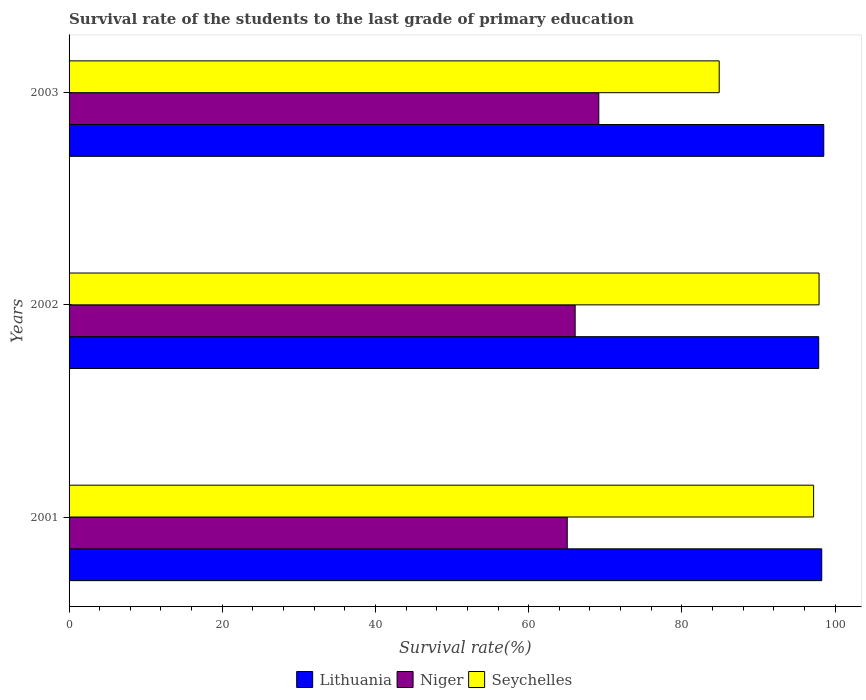How many different coloured bars are there?
Give a very brief answer. 3. Are the number of bars per tick equal to the number of legend labels?
Provide a succinct answer. Yes. Are the number of bars on each tick of the Y-axis equal?
Make the answer very short. Yes. How many bars are there on the 2nd tick from the top?
Make the answer very short. 3. How many bars are there on the 2nd tick from the bottom?
Provide a succinct answer. 3. What is the label of the 2nd group of bars from the top?
Provide a short and direct response. 2002. In how many cases, is the number of bars for a given year not equal to the number of legend labels?
Your answer should be very brief. 0. What is the survival rate of the students in Niger in 2002?
Your answer should be very brief. 66.07. Across all years, what is the maximum survival rate of the students in Niger?
Your answer should be compact. 69.16. Across all years, what is the minimum survival rate of the students in Seychelles?
Your answer should be very brief. 84.88. In which year was the survival rate of the students in Niger maximum?
Your answer should be compact. 2003. In which year was the survival rate of the students in Seychelles minimum?
Your answer should be very brief. 2003. What is the total survival rate of the students in Lithuania in the graph?
Provide a short and direct response. 294.67. What is the difference between the survival rate of the students in Lithuania in 2001 and that in 2003?
Keep it short and to the point. -0.26. What is the difference between the survival rate of the students in Niger in 2001 and the survival rate of the students in Seychelles in 2003?
Provide a short and direct response. -19.84. What is the average survival rate of the students in Seychelles per year?
Ensure brevity in your answer.  93.33. In the year 2001, what is the difference between the survival rate of the students in Seychelles and survival rate of the students in Niger?
Provide a succinct answer. 32.16. What is the ratio of the survival rate of the students in Lithuania in 2001 to that in 2002?
Keep it short and to the point. 1. Is the difference between the survival rate of the students in Seychelles in 2001 and 2002 greater than the difference between the survival rate of the students in Niger in 2001 and 2002?
Offer a terse response. Yes. What is the difference between the highest and the second highest survival rate of the students in Niger?
Offer a very short reply. 3.09. What is the difference between the highest and the lowest survival rate of the students in Seychelles?
Provide a succinct answer. 13.04. In how many years, is the survival rate of the students in Seychelles greater than the average survival rate of the students in Seychelles taken over all years?
Your answer should be compact. 2. Is the sum of the survival rate of the students in Niger in 2001 and 2002 greater than the maximum survival rate of the students in Seychelles across all years?
Offer a terse response. Yes. What does the 2nd bar from the top in 2003 represents?
Your answer should be very brief. Niger. What does the 3rd bar from the bottom in 2001 represents?
Make the answer very short. Seychelles. Is it the case that in every year, the sum of the survival rate of the students in Niger and survival rate of the students in Seychelles is greater than the survival rate of the students in Lithuania?
Offer a terse response. Yes. How many bars are there?
Offer a terse response. 9. Are all the bars in the graph horizontal?
Offer a very short reply. Yes. Does the graph contain any zero values?
Your response must be concise. No. Does the graph contain grids?
Provide a succinct answer. No. How are the legend labels stacked?
Provide a short and direct response. Horizontal. What is the title of the graph?
Your response must be concise. Survival rate of the students to the last grade of primary education. Does "Kiribati" appear as one of the legend labels in the graph?
Provide a short and direct response. No. What is the label or title of the X-axis?
Your answer should be compact. Survival rate(%). What is the label or title of the Y-axis?
Your answer should be compact. Years. What is the Survival rate(%) of Lithuania in 2001?
Give a very brief answer. 98.27. What is the Survival rate(%) in Niger in 2001?
Your answer should be very brief. 65.04. What is the Survival rate(%) in Seychelles in 2001?
Offer a terse response. 97.21. What is the Survival rate(%) in Lithuania in 2002?
Provide a short and direct response. 97.87. What is the Survival rate(%) of Niger in 2002?
Offer a very short reply. 66.07. What is the Survival rate(%) of Seychelles in 2002?
Provide a succinct answer. 97.92. What is the Survival rate(%) in Lithuania in 2003?
Offer a very short reply. 98.53. What is the Survival rate(%) of Niger in 2003?
Offer a terse response. 69.16. What is the Survival rate(%) in Seychelles in 2003?
Your answer should be very brief. 84.88. Across all years, what is the maximum Survival rate(%) of Lithuania?
Ensure brevity in your answer.  98.53. Across all years, what is the maximum Survival rate(%) of Niger?
Ensure brevity in your answer.  69.16. Across all years, what is the maximum Survival rate(%) of Seychelles?
Your response must be concise. 97.92. Across all years, what is the minimum Survival rate(%) of Lithuania?
Offer a terse response. 97.87. Across all years, what is the minimum Survival rate(%) of Niger?
Provide a succinct answer. 65.04. Across all years, what is the minimum Survival rate(%) in Seychelles?
Your answer should be compact. 84.88. What is the total Survival rate(%) of Lithuania in the graph?
Your response must be concise. 294.67. What is the total Survival rate(%) in Niger in the graph?
Your answer should be very brief. 200.28. What is the total Survival rate(%) in Seychelles in the graph?
Keep it short and to the point. 280. What is the difference between the Survival rate(%) in Lithuania in 2001 and that in 2002?
Offer a very short reply. 0.4. What is the difference between the Survival rate(%) in Niger in 2001 and that in 2002?
Offer a very short reply. -1.03. What is the difference between the Survival rate(%) of Seychelles in 2001 and that in 2002?
Ensure brevity in your answer.  -0.71. What is the difference between the Survival rate(%) of Lithuania in 2001 and that in 2003?
Offer a terse response. -0.26. What is the difference between the Survival rate(%) of Niger in 2001 and that in 2003?
Your response must be concise. -4.12. What is the difference between the Survival rate(%) in Seychelles in 2001 and that in 2003?
Your answer should be very brief. 12.33. What is the difference between the Survival rate(%) in Lithuania in 2002 and that in 2003?
Offer a very short reply. -0.66. What is the difference between the Survival rate(%) of Niger in 2002 and that in 2003?
Provide a succinct answer. -3.09. What is the difference between the Survival rate(%) in Seychelles in 2002 and that in 2003?
Offer a very short reply. 13.04. What is the difference between the Survival rate(%) in Lithuania in 2001 and the Survival rate(%) in Niger in 2002?
Give a very brief answer. 32.2. What is the difference between the Survival rate(%) in Lithuania in 2001 and the Survival rate(%) in Seychelles in 2002?
Give a very brief answer. 0.35. What is the difference between the Survival rate(%) of Niger in 2001 and the Survival rate(%) of Seychelles in 2002?
Your response must be concise. -32.88. What is the difference between the Survival rate(%) of Lithuania in 2001 and the Survival rate(%) of Niger in 2003?
Keep it short and to the point. 29.11. What is the difference between the Survival rate(%) in Lithuania in 2001 and the Survival rate(%) in Seychelles in 2003?
Provide a short and direct response. 13.39. What is the difference between the Survival rate(%) in Niger in 2001 and the Survival rate(%) in Seychelles in 2003?
Ensure brevity in your answer.  -19.84. What is the difference between the Survival rate(%) of Lithuania in 2002 and the Survival rate(%) of Niger in 2003?
Ensure brevity in your answer.  28.71. What is the difference between the Survival rate(%) in Lithuania in 2002 and the Survival rate(%) in Seychelles in 2003?
Your answer should be compact. 12.99. What is the difference between the Survival rate(%) of Niger in 2002 and the Survival rate(%) of Seychelles in 2003?
Offer a very short reply. -18.81. What is the average Survival rate(%) in Lithuania per year?
Provide a short and direct response. 98.22. What is the average Survival rate(%) of Niger per year?
Provide a succinct answer. 66.76. What is the average Survival rate(%) of Seychelles per year?
Provide a succinct answer. 93.33. In the year 2001, what is the difference between the Survival rate(%) in Lithuania and Survival rate(%) in Niger?
Provide a succinct answer. 33.23. In the year 2001, what is the difference between the Survival rate(%) of Lithuania and Survival rate(%) of Seychelles?
Give a very brief answer. 1.06. In the year 2001, what is the difference between the Survival rate(%) of Niger and Survival rate(%) of Seychelles?
Your response must be concise. -32.16. In the year 2002, what is the difference between the Survival rate(%) of Lithuania and Survival rate(%) of Niger?
Keep it short and to the point. 31.8. In the year 2002, what is the difference between the Survival rate(%) in Lithuania and Survival rate(%) in Seychelles?
Your answer should be very brief. -0.04. In the year 2002, what is the difference between the Survival rate(%) of Niger and Survival rate(%) of Seychelles?
Provide a short and direct response. -31.84. In the year 2003, what is the difference between the Survival rate(%) in Lithuania and Survival rate(%) in Niger?
Your answer should be very brief. 29.37. In the year 2003, what is the difference between the Survival rate(%) in Lithuania and Survival rate(%) in Seychelles?
Make the answer very short. 13.65. In the year 2003, what is the difference between the Survival rate(%) in Niger and Survival rate(%) in Seychelles?
Keep it short and to the point. -15.72. What is the ratio of the Survival rate(%) of Lithuania in 2001 to that in 2002?
Keep it short and to the point. 1. What is the ratio of the Survival rate(%) of Niger in 2001 to that in 2002?
Offer a terse response. 0.98. What is the ratio of the Survival rate(%) of Niger in 2001 to that in 2003?
Your answer should be very brief. 0.94. What is the ratio of the Survival rate(%) of Seychelles in 2001 to that in 2003?
Provide a short and direct response. 1.15. What is the ratio of the Survival rate(%) in Lithuania in 2002 to that in 2003?
Give a very brief answer. 0.99. What is the ratio of the Survival rate(%) in Niger in 2002 to that in 2003?
Your answer should be very brief. 0.96. What is the ratio of the Survival rate(%) of Seychelles in 2002 to that in 2003?
Provide a short and direct response. 1.15. What is the difference between the highest and the second highest Survival rate(%) of Lithuania?
Your answer should be very brief. 0.26. What is the difference between the highest and the second highest Survival rate(%) of Niger?
Your answer should be very brief. 3.09. What is the difference between the highest and the second highest Survival rate(%) of Seychelles?
Provide a succinct answer. 0.71. What is the difference between the highest and the lowest Survival rate(%) in Lithuania?
Your answer should be very brief. 0.66. What is the difference between the highest and the lowest Survival rate(%) in Niger?
Your response must be concise. 4.12. What is the difference between the highest and the lowest Survival rate(%) of Seychelles?
Give a very brief answer. 13.04. 